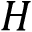<formula> <loc_0><loc_0><loc_500><loc_500>H</formula> 